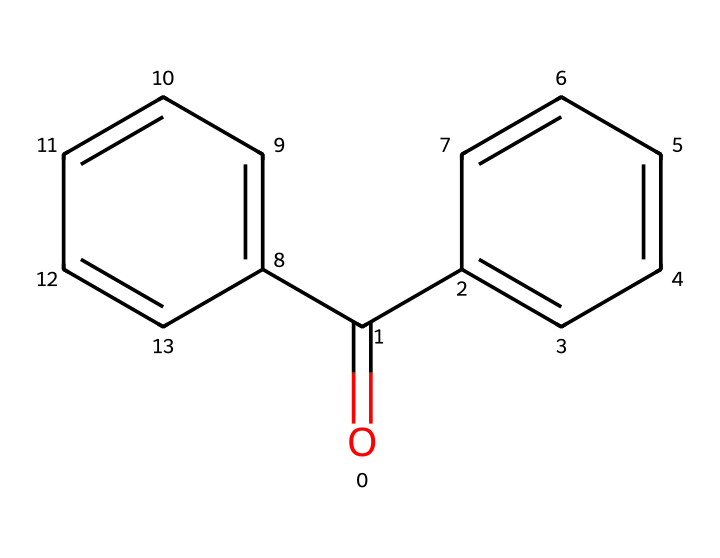What is the molecular formula of benzophenone? To determine the molecular formula from the SMILES representation, we identify the constituent atoms. The structure indicates the presence of two phenyl groups (C6H5) and one carbonyl group (C=O). Thus, counting carbons, we have 13 from the two phenyl groups and one from the carbonyl, along with one oxygen: C13H10O.
Answer: C13H10O How many rings are present in the benzophenone structure? The SMILES shows two distinct phenyl groups, implying two aromatic rings. Since no additional cyclic structures or other rings are drawn, the total count is two.
Answer: 2 What type of functional group is present in benzophenone? The SMILES indicates a carbonyl (C=O) linked to the aromatic rings, which classifies it as a ketone due to its location between two carbon atoms, characterizing benzophenone specifically.
Answer: ketone What is the primary role of benzophenone in disinfectant-resistant coatings? Benzophenone functions mainly as a UV absorber to protect the coating from degradation due to UV exposure, thereby enhancing the longevity and effectiveness of the disinfectant properties on surfaces.
Answer: UV absorber What is the total number of hydrogen atoms in benzophenone? By analyzing the structure, we count the hydrogen atoms. Each phenyl group contributes five hydrogen atoms, and due to the carbonyl, the total comes to 10 hydrogen atoms.
Answer: 10 What characteristic of benzophenone contributes to its stability in disinfectant coatings? The presence of aromatic rings imparts electronic stability due to delocalized electrons, making the compound less reactive and helping maintain the integrity of disinfectant coatings.
Answer: delocalized electrons 